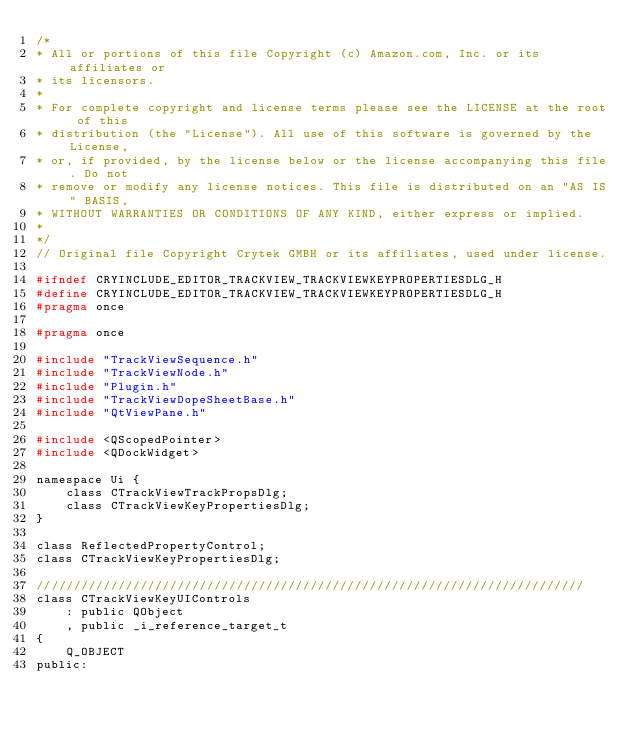<code> <loc_0><loc_0><loc_500><loc_500><_C_>/*
* All or portions of this file Copyright (c) Amazon.com, Inc. or its affiliates or
* its licensors.
*
* For complete copyright and license terms please see the LICENSE at the root of this
* distribution (the "License"). All use of this software is governed by the License,
* or, if provided, by the license below or the license accompanying this file. Do not
* remove or modify any license notices. This file is distributed on an "AS IS" BASIS,
* WITHOUT WARRANTIES OR CONDITIONS OF ANY KIND, either express or implied.
*
*/
// Original file Copyright Crytek GMBH or its affiliates, used under license.

#ifndef CRYINCLUDE_EDITOR_TRACKVIEW_TRACKVIEWKEYPROPERTIESDLG_H
#define CRYINCLUDE_EDITOR_TRACKVIEW_TRACKVIEWKEYPROPERTIESDLG_H
#pragma once

#pragma once

#include "TrackViewSequence.h"
#include "TrackViewNode.h"
#include "Plugin.h"
#include "TrackViewDopeSheetBase.h"
#include "QtViewPane.h"

#include <QScopedPointer>
#include <QDockWidget>

namespace Ui {
    class CTrackViewTrackPropsDlg;
    class CTrackViewKeyPropertiesDlg;
}

class ReflectedPropertyControl;
class CTrackViewKeyPropertiesDlg;

//////////////////////////////////////////////////////////////////////////
class CTrackViewKeyUIControls
    : public QObject
    , public _i_reference_target_t
{
    Q_OBJECT
public:</code> 